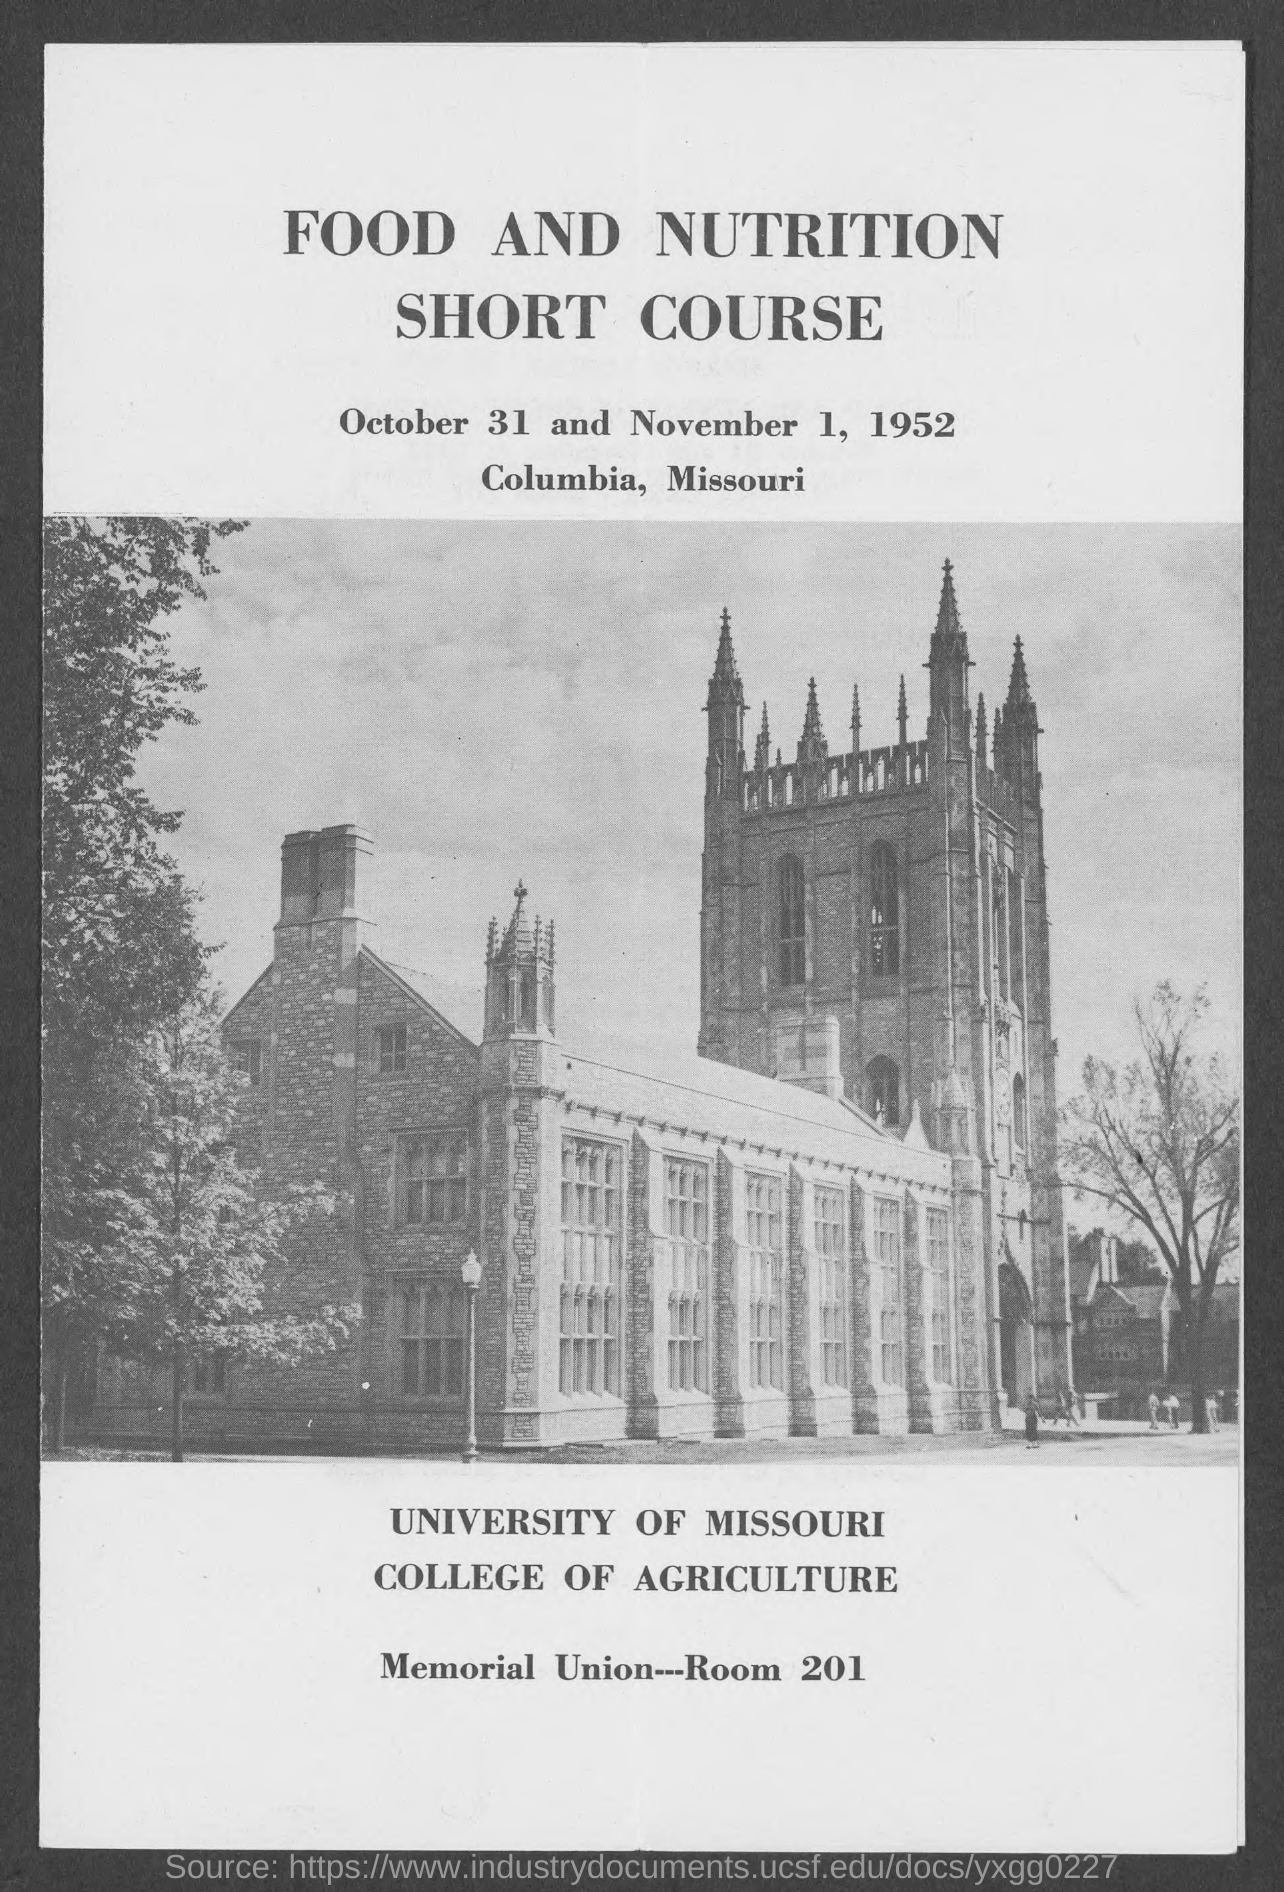When is the course?
Keep it short and to the point. OCTOBER 31 AND NOVEMBER 1, 1952. Where is the course?
Provide a succinct answer. COLUMBIA, MISSOURI. Where is the Memorial Union?
Offer a very short reply. Room 201. Which university is mentioned?
Make the answer very short. University of missouri. Which college is mentioned?
Ensure brevity in your answer.  College of agriculture. 